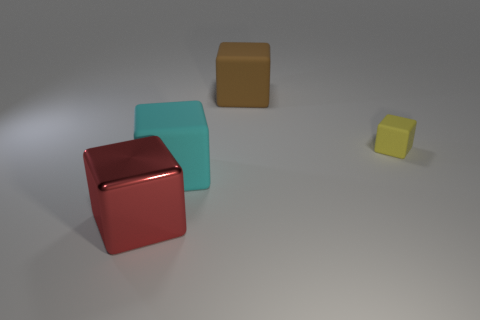Subtract all cyan rubber blocks. How many blocks are left? 3 Subtract all brown cubes. How many cubes are left? 3 Subtract all blue blocks. Subtract all brown cylinders. How many blocks are left? 4 Add 4 large brown rubber blocks. How many objects exist? 8 Subtract 0 gray cylinders. How many objects are left? 4 Subtract all yellow blocks. Subtract all big rubber cubes. How many objects are left? 1 Add 2 yellow matte things. How many yellow matte things are left? 3 Add 4 large red cubes. How many large red cubes exist? 5 